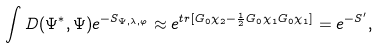<formula> <loc_0><loc_0><loc_500><loc_500>\int D ( \Psi ^ { * } , \Psi ) e ^ { - S _ { \Psi , \lambda , \varphi } } \approx e ^ { t r [ G _ { 0 } \chi _ { 2 } - \frac { 1 } { 2 } G _ { 0 } \chi _ { 1 } G _ { 0 } \chi _ { 1 } ] } = e ^ { - S ^ { \prime } } ,</formula> 